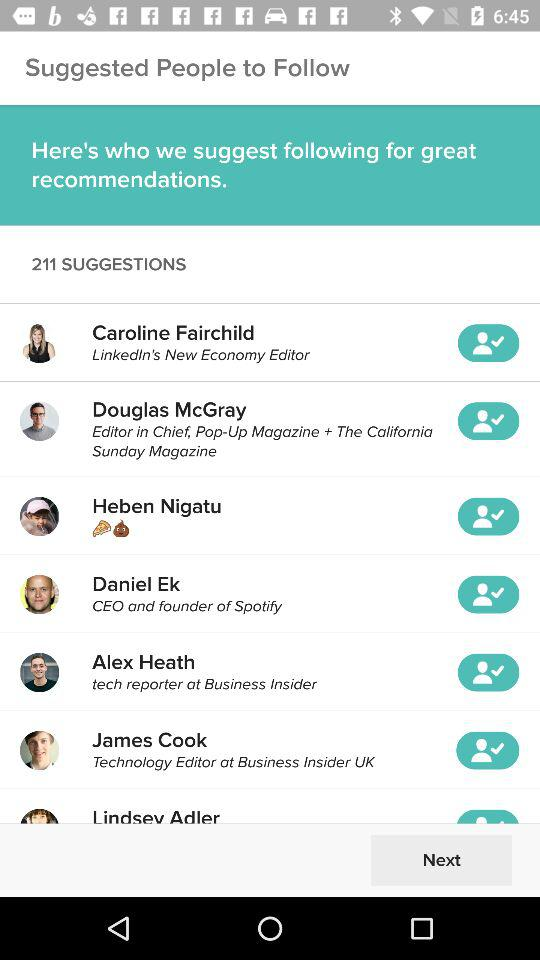What is the name of the CEO and founder of "Spotify"? The name of the CEO and founder is Daniel Ek. 